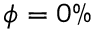Convert formula to latex. <formula><loc_0><loc_0><loc_500><loc_500>\phi = 0 \%</formula> 